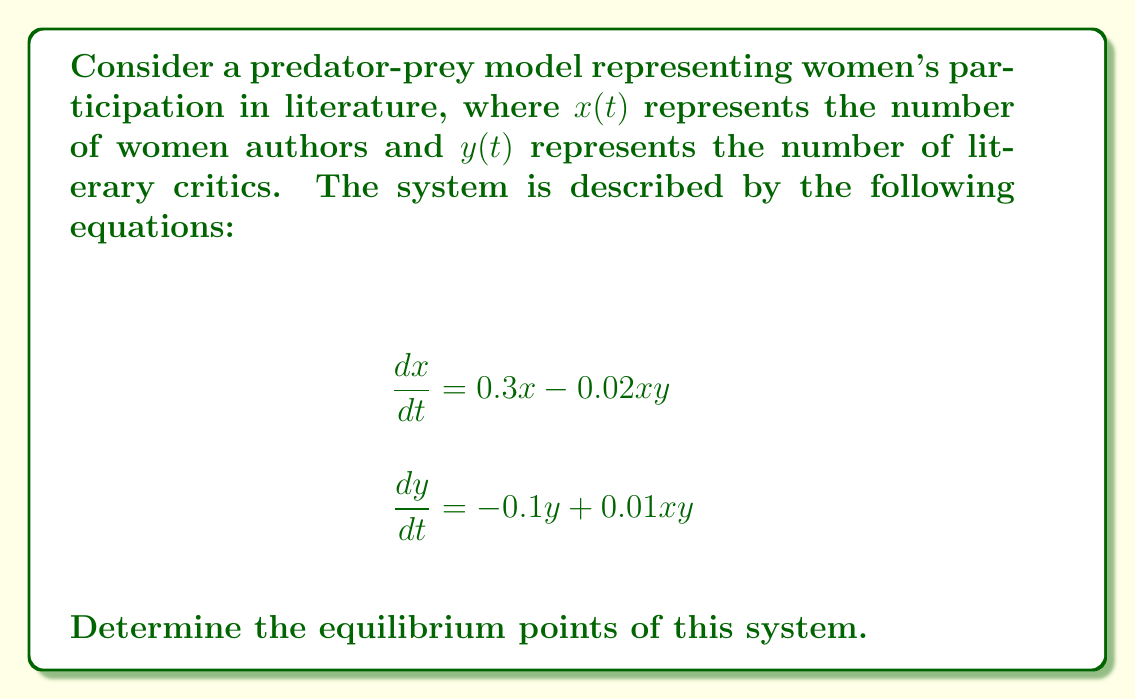Help me with this question. To find the equilibrium points, we set both equations equal to zero and solve for $x$ and $y$:

1) Set $\frac{dx}{dt} = 0$ and $\frac{dy}{dt} = 0$:
   
   $0.3x - 0.02xy = 0$
   $-0.1y + 0.01xy = 0$

2) From the first equation:
   $x(0.3 - 0.02y) = 0$
   This gives us two cases: $x = 0$ or $0.3 - 0.02y = 0$

3) Case 1: If $x = 0$, substitute into the second equation:
   $-0.1y = 0$
   $y = 0$
   So, $(0, 0)$ is an equilibrium point.

4) Case 2: If $0.3 - 0.02y = 0$, solve for $y$:
   $y = 15$
   
   Substitute $y = 15$ into the second equation:
   $-0.1(15) + 0.01x(15) = 0$
   $-1.5 + 0.15x = 0$
   $0.15x = 1.5$
   $x = 10$

   So, $(10, 15)$ is another equilibrium point.

Therefore, the system has two equilibrium points: $(0, 0)$ and $(10, 15)$.
Answer: $(0, 0)$ and $(10, 15)$ 